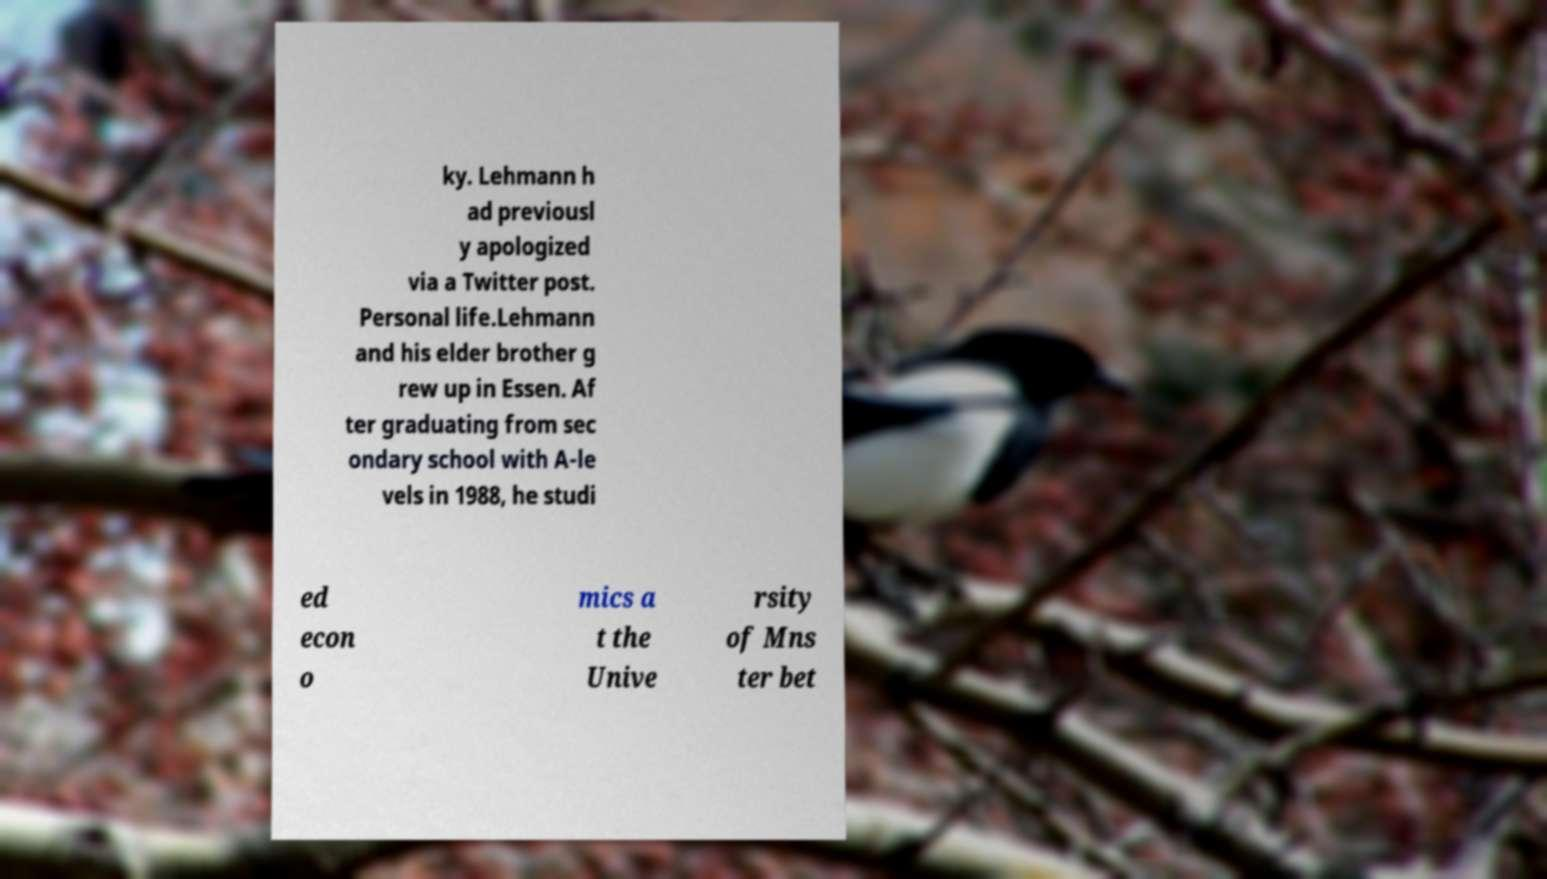Please identify and transcribe the text found in this image. ky. Lehmann h ad previousl y apologized via a Twitter post. Personal life.Lehmann and his elder brother g rew up in Essen. Af ter graduating from sec ondary school with A-le vels in 1988, he studi ed econ o mics a t the Unive rsity of Mns ter bet 